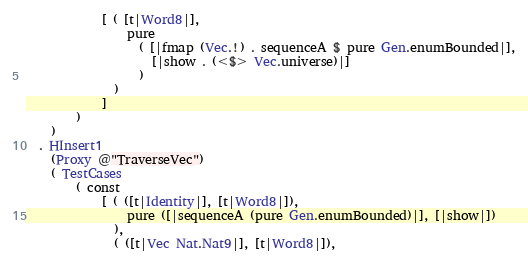<code> <loc_0><loc_0><loc_500><loc_500><_Haskell_>            [ ( [t|Word8|],
                pure
                  ( [|fmap (Vec.!) . sequenceA $ pure Gen.enumBounded|],
                    [|show . (<$> Vec.universe)|]
                  )
              )
            ]
        )
    )
  . HInsert1
    (Proxy @"TraverseVec")
    ( TestCases
        ( const
            [ ( ([t|Identity|], [t|Word8|]),
                pure ([|sequenceA (pure Gen.enumBounded)|], [|show|])
              ),
              ( ([t|Vec Nat.Nat9|], [t|Word8|]),</code> 